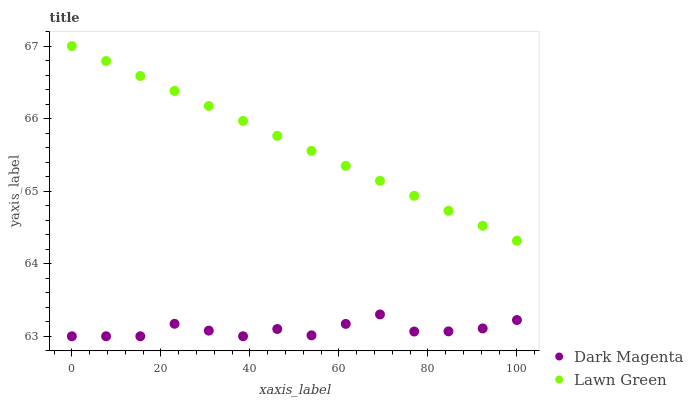Does Dark Magenta have the minimum area under the curve?
Answer yes or no. Yes. Does Lawn Green have the maximum area under the curve?
Answer yes or no. Yes. Does Dark Magenta have the maximum area under the curve?
Answer yes or no. No. Is Lawn Green the smoothest?
Answer yes or no. Yes. Is Dark Magenta the roughest?
Answer yes or no. Yes. Is Dark Magenta the smoothest?
Answer yes or no. No. Does Dark Magenta have the lowest value?
Answer yes or no. Yes. Does Lawn Green have the highest value?
Answer yes or no. Yes. Does Dark Magenta have the highest value?
Answer yes or no. No. Is Dark Magenta less than Lawn Green?
Answer yes or no. Yes. Is Lawn Green greater than Dark Magenta?
Answer yes or no. Yes. Does Dark Magenta intersect Lawn Green?
Answer yes or no. No. 